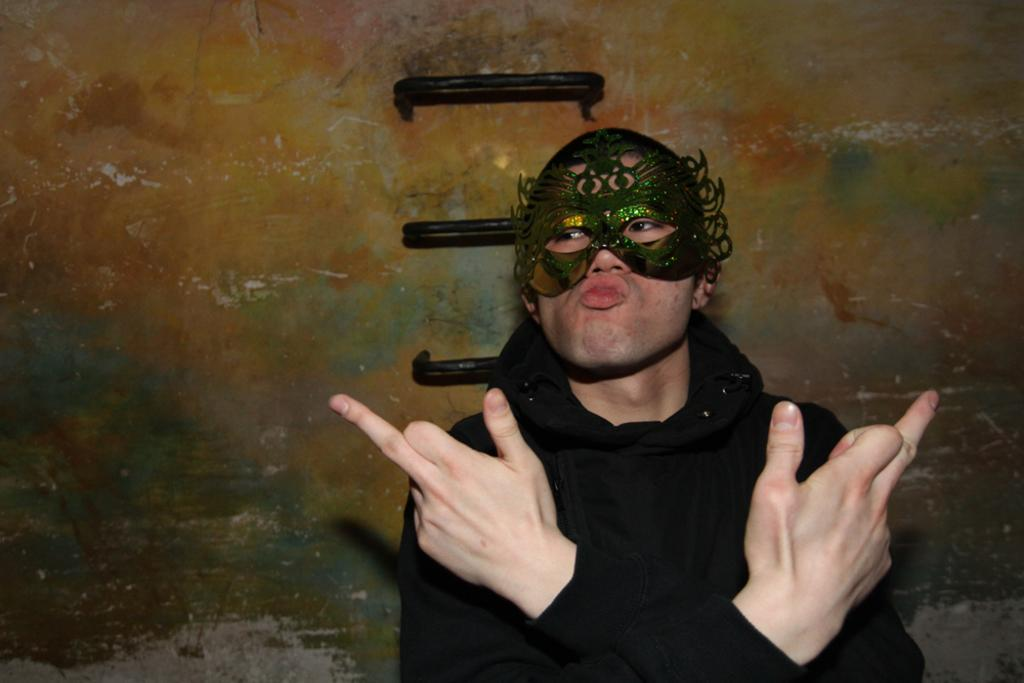Who or what is the main subject in the image? There is a person in the image. What is the person wearing on their face? The person is wearing a mask. Where is the person located in relation to the image? The person is in the foreground area of the image. What can be seen behind the person in the image? There appears to be a wall in the background of the image. What type of bird can be seen perched on the branch in the image? There is no bird or branch present in the image; it features a person wearing a mask in the foreground and a wall in the background. 